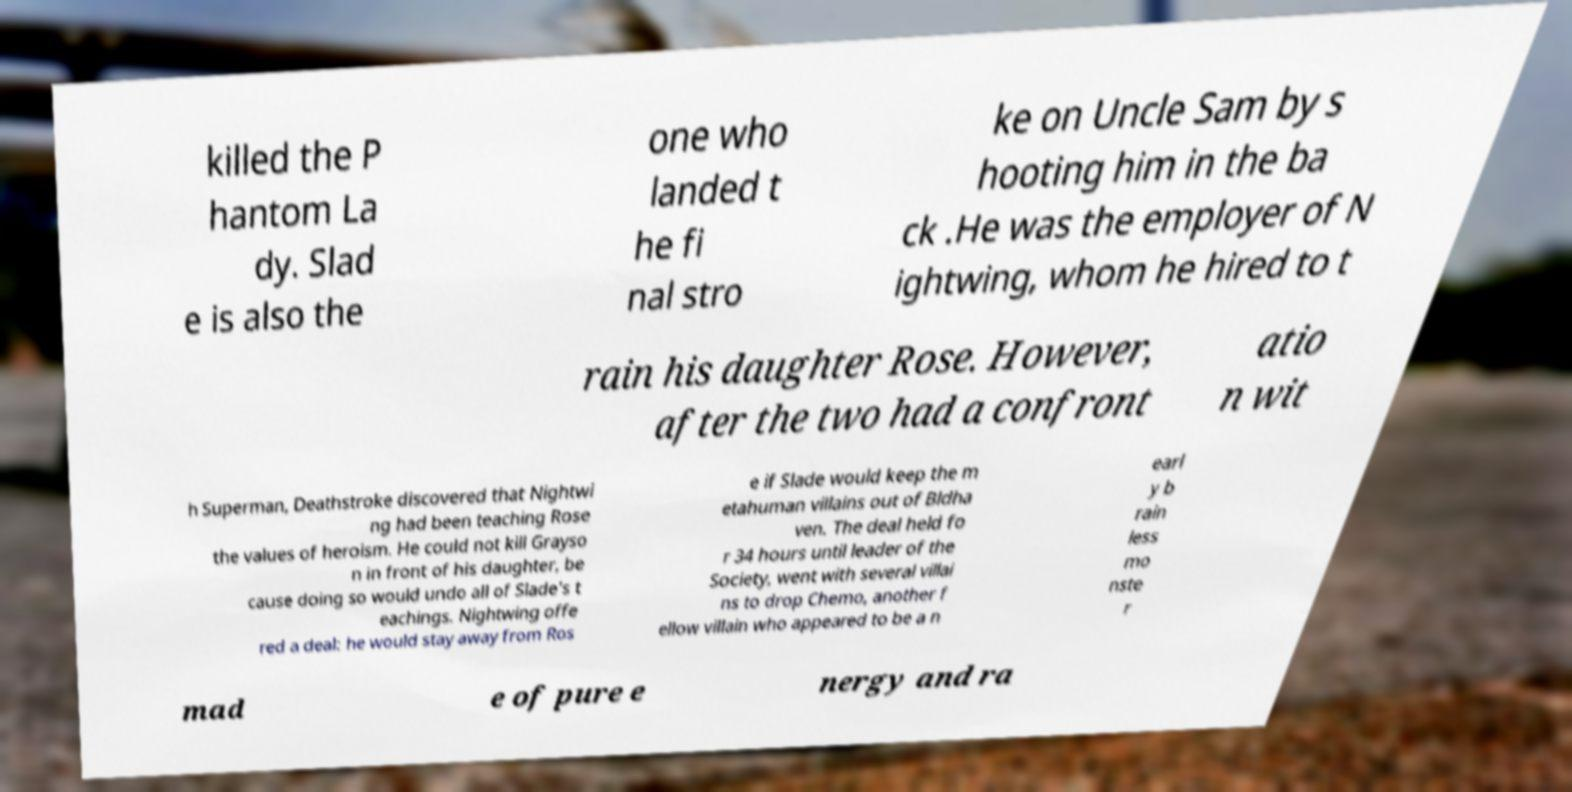Could you assist in decoding the text presented in this image and type it out clearly? killed the P hantom La dy. Slad e is also the one who landed t he fi nal stro ke on Uncle Sam by s hooting him in the ba ck .He was the employer of N ightwing, whom he hired to t rain his daughter Rose. However, after the two had a confront atio n wit h Superman, Deathstroke discovered that Nightwi ng had been teaching Rose the values of heroism. He could not kill Grayso n in front of his daughter, be cause doing so would undo all of Slade's t eachings. Nightwing offe red a deal: he would stay away from Ros e if Slade would keep the m etahuman villains out of Bldha ven. The deal held fo r 34 hours until leader of the Society, went with several villai ns to drop Chemo, another f ellow villain who appeared to be a n earl y b rain less mo nste r mad e of pure e nergy and ra 